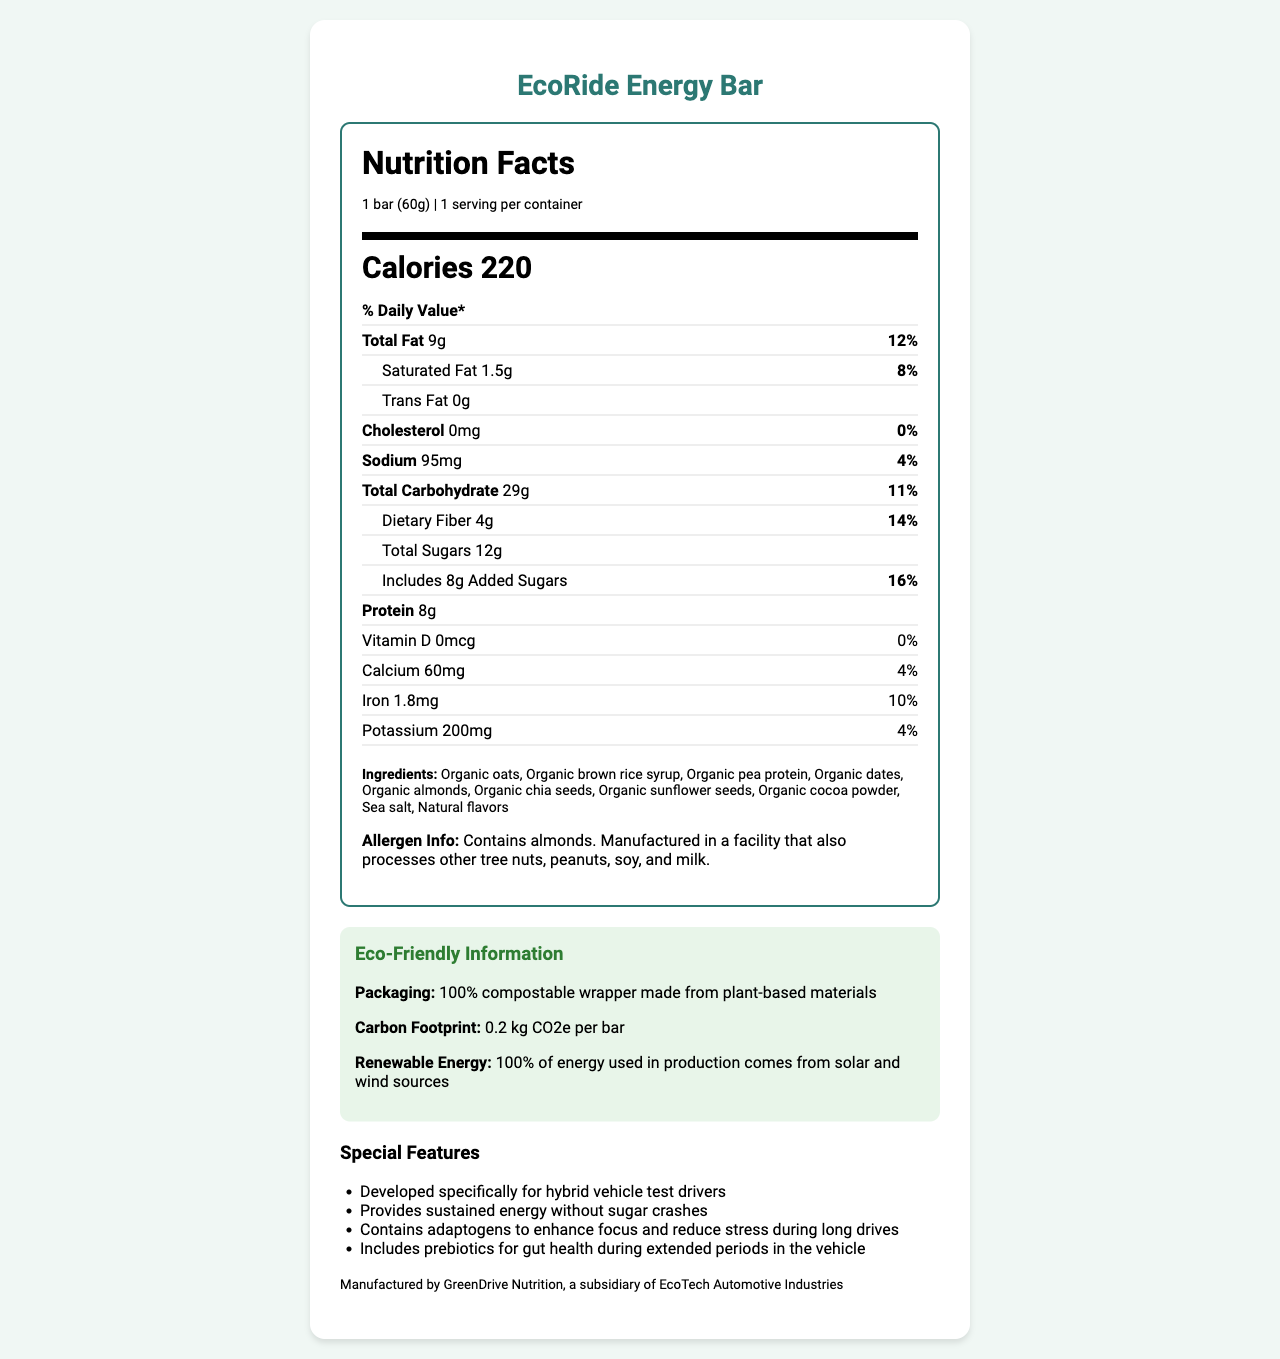what is the serving size? The document mentions that the serving size is 1 bar weighing 60 grams.
Answer: 1 bar (60g) how many calories are there in one EcoRide Energy Bar? The document states that each bar contains 220 calories.
Answer: 220 what is the total fat content, and its percentage of the daily value? The document specifies that the total fat content is 9 grams, and it represents 12% of the daily value.
Answer: 9g, 12% how much dietary fiber does the EcoRide Energy Bar have? According to the document, the dietary fiber amount is 4 grams.
Answer: 4g what is the amount of added sugars, and its percentage of the daily value? The document shows that the bar contains 8 grams of added sugars, which is 16% of the daily value.
Answer: 8g, 16% which renewable energy sources are used in the production of EcoRide Energy Bar? The document indicates that 100% of the energy used in production comes from solar and wind sources.
Answer: Solar and wind what is the carbon footprint per bar? The document specifies that the carbon footprint is 0.2 kg CO2e per bar.
Answer: 0.2 kg CO2e per bar does the EcoRide Energy Bar contain any cholesterol? The document states that there is 0mg of cholesterol, contributing 0% to the daily value.
Answer: No is there any allergen information provided for the EcoRide Energy Bar? The document mentions that the bar contains almonds and is manufactured in a facility that also processes other tree nuts, peanuts, soy, and milk.
Answer: Yes which nutrient has the highest daily value percentage? A. Total Fat B. Added Sugars C. Dietary Fiber D. Calcium The document indicates that added sugars have a daily value of 16%, which is higher than total fat (12%), dietary fiber (14%), and calcium (4%).
Answer: B. Added Sugars what special feature is designed to enhance focus and reduce stress? 1. Prebiotics for gut health 2. Adaptogens 3. 100% compostable wrapper 4. Low sodium content The document states that the bar contains adaptogens to enhance focus and reduce stress during long drives.
Answer: 2. Adaptogens did GreenDrive Nutrition manufacture the EcoRide Energy Bar? The document mentions that the bar is manufactured by GreenDrive Nutrition, a subsidiary of EcoTech Automotive Industries.
Answer: Yes what is the main idea of the document? The document covers various aspects such as serving size, calories, specific nutrient quantities, special features, eco-friendly packaging, use of renewable energy, and manufacturing details.
Answer: The document provides detailed nutrition facts and eco-friendly information about the EcoRide Energy Bar, a premium, low-carbon footprint snack developed for hybrid vehicle test drivers, highlighting its ingredients, nutritional benefits, allergen information, and sustainability efforts. which ingredient in EcoRide Energy Bar is not organic? The document lists all ingredients as organic, so based on the visual information, we cannot determine if any non-organic ingredients are used.
Answer: Cannot be determined 